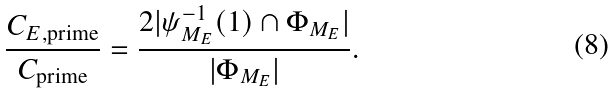Convert formula to latex. <formula><loc_0><loc_0><loc_500><loc_500>\frac { C _ { E , \text {prime} } } { C _ { \text {prime} } } = \frac { 2 | \psi _ { M _ { E } } ^ { - 1 } ( 1 ) \cap \Phi _ { M _ { E } } | } { | \Phi _ { M _ { E } } | } .</formula> 